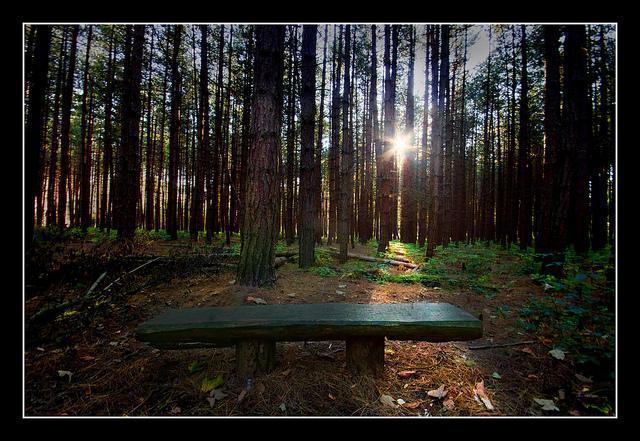How many places are there to sit down?
Give a very brief answer. 1. How many fire hydrants are there?
Give a very brief answer. 0. 